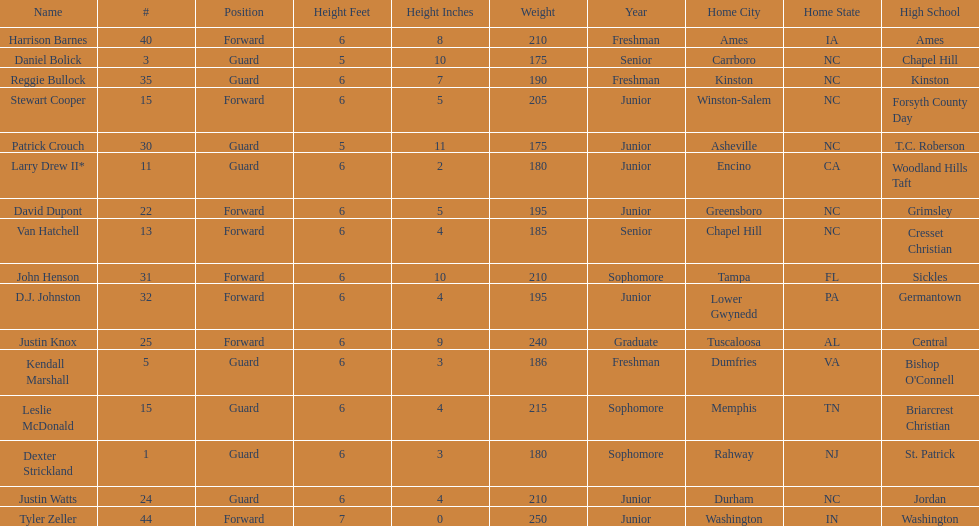Tallest player on the team Tyler Zeller. 